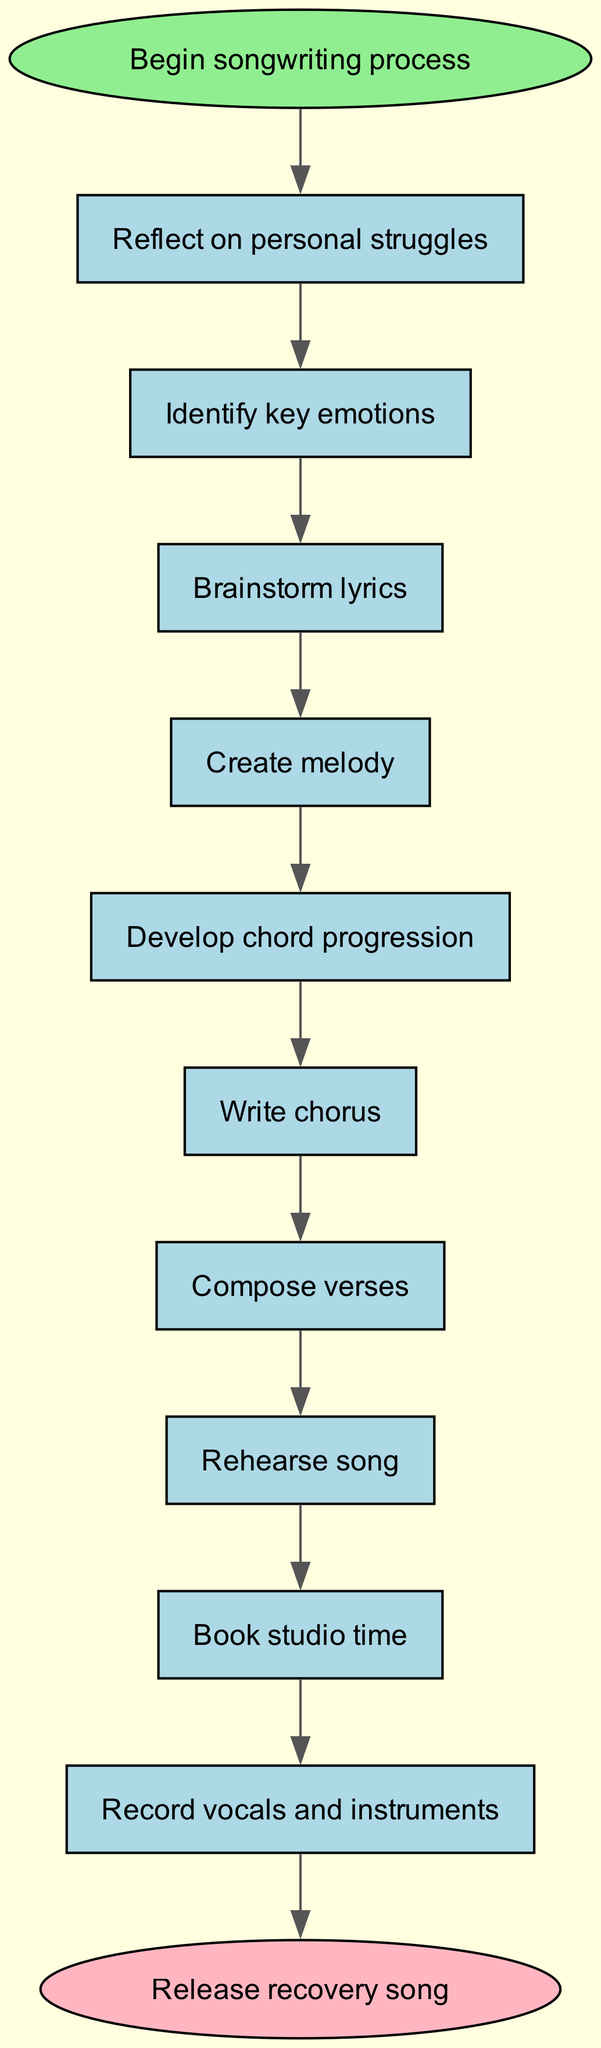What is the starting point of the songwriter process? The diagram indicates that the starting point is labeled "Begin songwriting process." It's the first node before any steps are outlined.
Answer: Begin songwriting process How many steps are there in the songwriting process? By counting each individual step listed in the diagram, including the last one leading to the end node, there are ten steps in total.
Answer: 10 What comes after "Develop chord progression"? The diagram clearly shows that after this step, the next one is "Write chorus." This follows the directional flow from one step to the next.
Answer: Write chorus What is the last step before releasing the recovery song? The last step before reaching the end labeled "Release recovery song" is "Mix and master track," which is directly connected to the end node.
Answer: Mix and master track Which step directly follows "Compose verses"? The flow chart shows that "Rehearse song" directly follows after "Compose verses," indicating the next action to take.
Answer: Rehearse song How do you go from "Identify key emotions" to "Develop chord progression"? To reach "Develop chord progression," you must first pass through "Identify key emotions," then "Brainstorm lyrics," and "Create melody," according to the sequential flow outlined in the diagram.
Answer: Through two additional steps What type of node is used to represent the end of the song process? The last node in the diagram that denotes the conclusion of the process is characterized as an ellipse, specifically labeled "Release recovery song."
Answer: Ellipse What is the function of the first step in the process? The first step labeled "Reflect on personal struggles" serves the primary role of initiating the songwriting process by prompting self-reflection on personal experiences, which is crucial for crafting the song.
Answer: Initiate self-reflection Is there a step after "Book studio time"? According to the diagram, "Book studio time" is directly followed by the next step "Record vocals and instruments," indicating that this action comes before the final steps.
Answer: Yes, Record vocals and instruments 